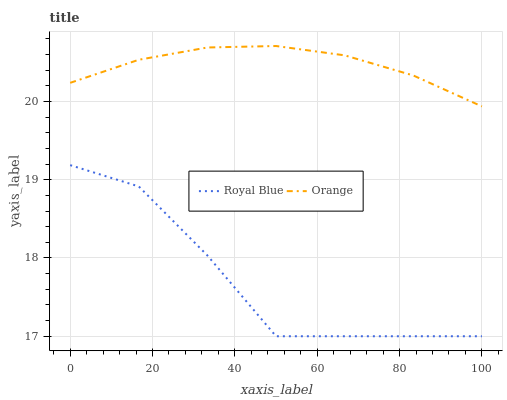Does Royal Blue have the minimum area under the curve?
Answer yes or no. Yes. Does Orange have the maximum area under the curve?
Answer yes or no. Yes. Does Royal Blue have the maximum area under the curve?
Answer yes or no. No. Is Orange the smoothest?
Answer yes or no. Yes. Is Royal Blue the roughest?
Answer yes or no. Yes. Is Royal Blue the smoothest?
Answer yes or no. No. Does Royal Blue have the lowest value?
Answer yes or no. Yes. Does Orange have the highest value?
Answer yes or no. Yes. Does Royal Blue have the highest value?
Answer yes or no. No. Is Royal Blue less than Orange?
Answer yes or no. Yes. Is Orange greater than Royal Blue?
Answer yes or no. Yes. Does Royal Blue intersect Orange?
Answer yes or no. No. 